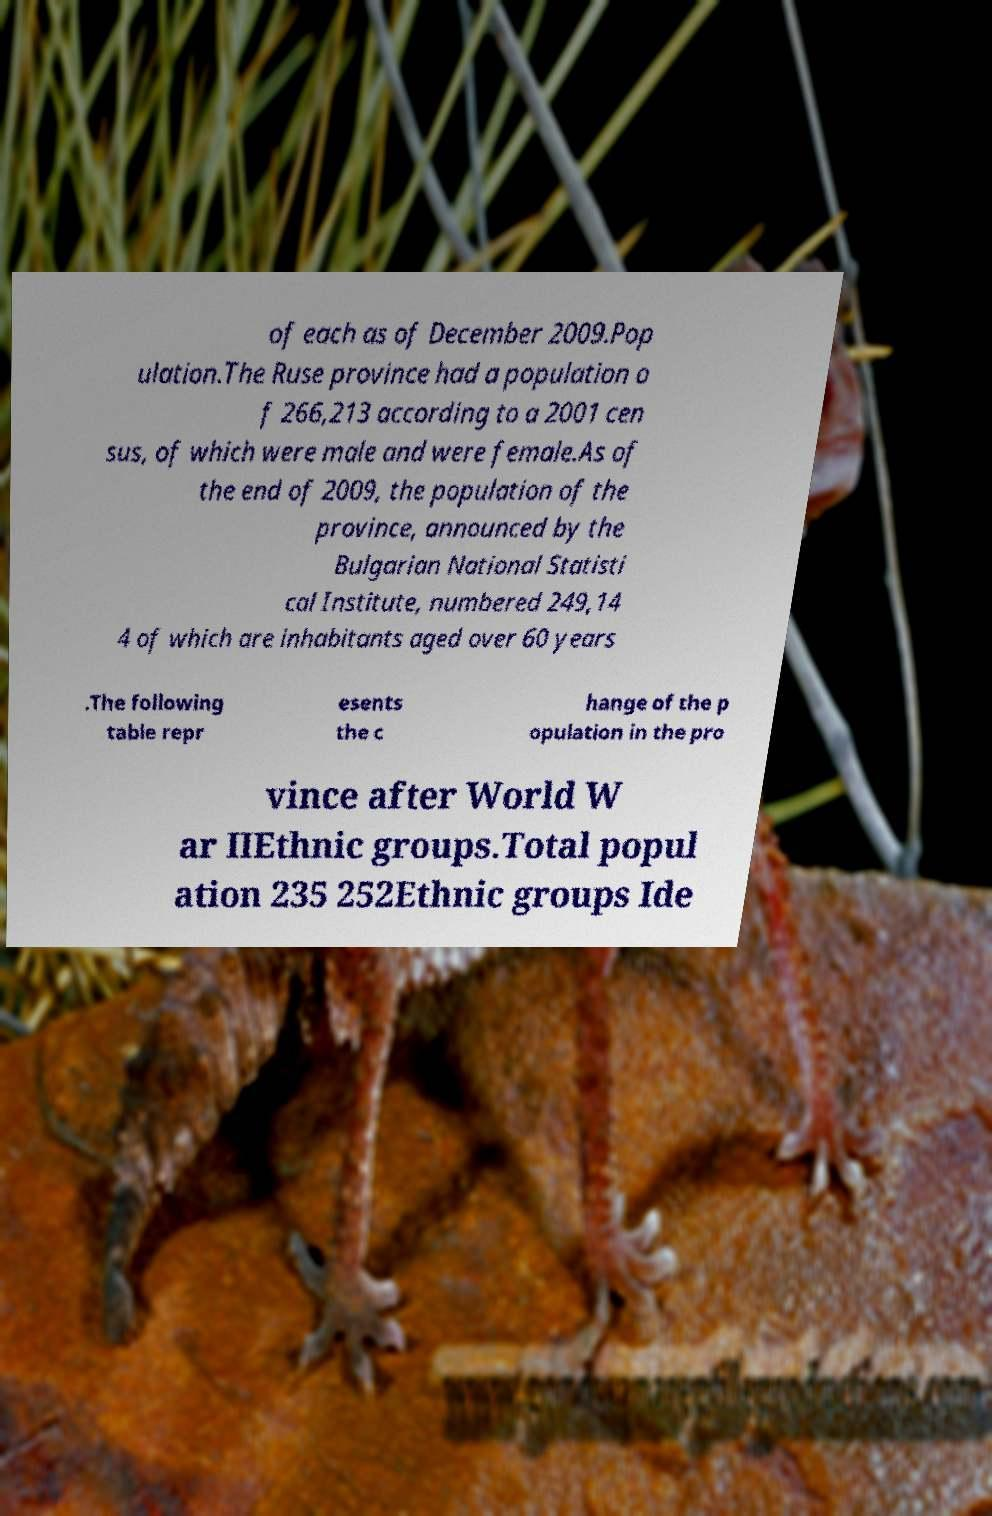I need the written content from this picture converted into text. Can you do that? of each as of December 2009.Pop ulation.The Ruse province had a population o f 266,213 according to a 2001 cen sus, of which were male and were female.As of the end of 2009, the population of the province, announced by the Bulgarian National Statisti cal Institute, numbered 249,14 4 of which are inhabitants aged over 60 years .The following table repr esents the c hange of the p opulation in the pro vince after World W ar IIEthnic groups.Total popul ation 235 252Ethnic groups Ide 